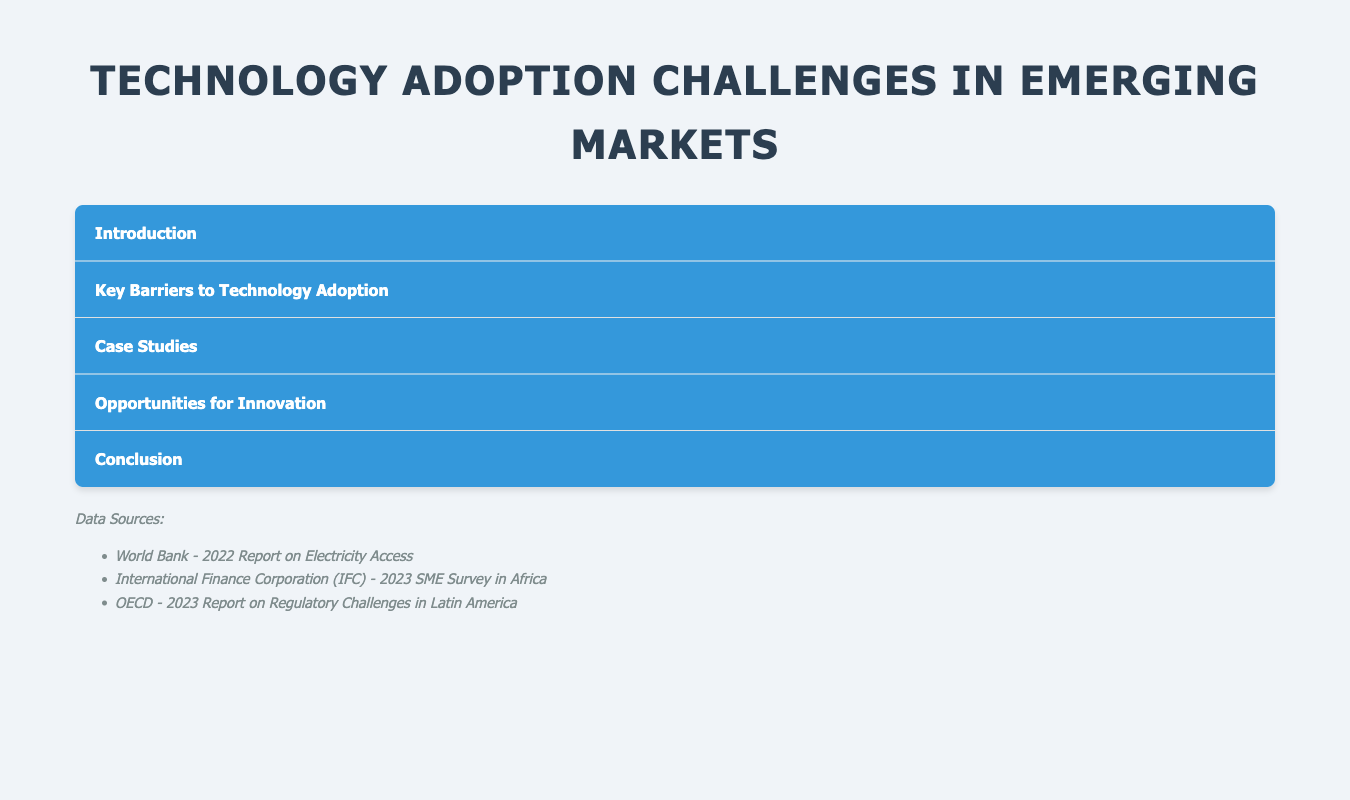What is the primary reason for limited technology access? The document states that inconsistent power supply, limited internet connectivity, and inadequate digital infrastructure hinder technology access.
Answer: Infrastructure Limitations What percentage of SMEs in Africa cite cost as a primary barrier? According to a survey conducted by the International Finance Corporation (IFC) in 2023, 70% of SMEs in Africa cite cost as a primary barrier.
Answer: 70% What is the cultural factor that can inhibit technology uptake? The document identifies entrenched traditional practices and resistance to change as cultural factors that inhibit technology uptake.
Answer: Cultural Resistance What is one case study mentioned in the document? The document lists case studies including M-Pesa in Kenya and E-learning Platforms in Nigeria.
Answer: M-Pesa in Kenya How long do regulatory uncertainties delay technology investments in Latin America? The OECD report states that regulatory uncertainties delay technology investments in Latin America by an average of 18 months.
Answer: 18 months What is one opportunity for innovation mentioned in the document? The document suggests opportunities for innovation in mobile technology, fintech, and renewable energy systems.
Answer: Mobile technology What is the workforce skill gap percentage reported in Southeast Asia? Local entrepreneurs in Southeast Asia report that about 60% of workers lack adequate digital skills for the emerging tech landscape.
Answer: 60% Who authored the 2022 Report on Electricity Access? The document attributes the 2022 Report on Electricity Access to the World Bank.
Answer: World Bank What is the aim of the strategies mentioned in the conclusion? The conclusion emphasizes that entrepreneurs must strategize to leverage local resources, adapt to cultural contexts, and advocate for supportive regulations.
Answer: Unlock significant growth opportunities 